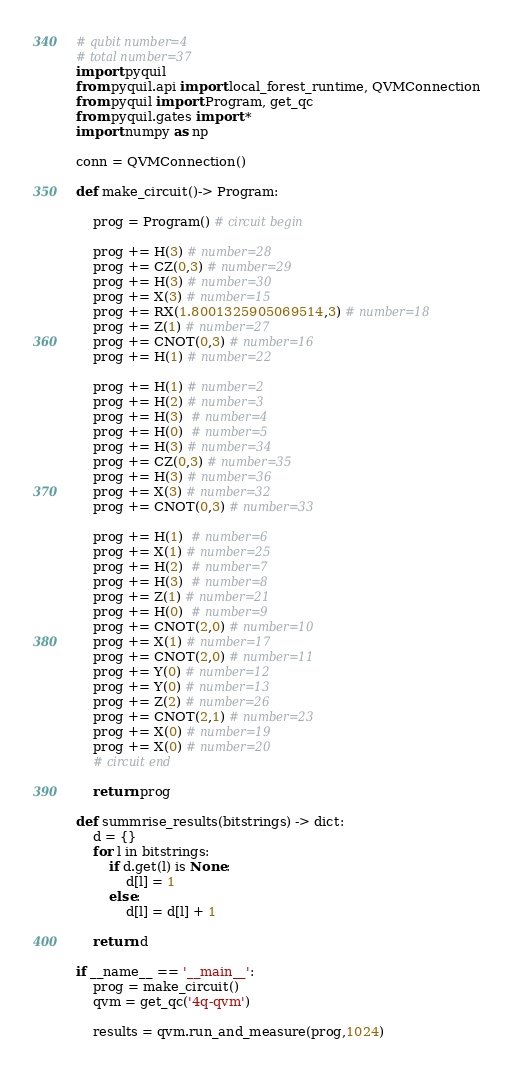Convert code to text. <code><loc_0><loc_0><loc_500><loc_500><_Python_># qubit number=4
# total number=37
import pyquil
from pyquil.api import local_forest_runtime, QVMConnection
from pyquil import Program, get_qc
from pyquil.gates import *
import numpy as np

conn = QVMConnection()

def make_circuit()-> Program:

    prog = Program() # circuit begin

    prog += H(3) # number=28
    prog += CZ(0,3) # number=29
    prog += H(3) # number=30
    prog += X(3) # number=15
    prog += RX(1.8001325905069514,3) # number=18
    prog += Z(1) # number=27
    prog += CNOT(0,3) # number=16
    prog += H(1) # number=22

    prog += H(1) # number=2
    prog += H(2) # number=3
    prog += H(3)  # number=4
    prog += H(0)  # number=5
    prog += H(3) # number=34
    prog += CZ(0,3) # number=35
    prog += H(3) # number=36
    prog += X(3) # number=32
    prog += CNOT(0,3) # number=33

    prog += H(1)  # number=6
    prog += X(1) # number=25
    prog += H(2)  # number=7
    prog += H(3)  # number=8
    prog += Z(1) # number=21
    prog += H(0)  # number=9
    prog += CNOT(2,0) # number=10
    prog += X(1) # number=17
    prog += CNOT(2,0) # number=11
    prog += Y(0) # number=12
    prog += Y(0) # number=13
    prog += Z(2) # number=26
    prog += CNOT(2,1) # number=23
    prog += X(0) # number=19
    prog += X(0) # number=20
    # circuit end

    return prog

def summrise_results(bitstrings) -> dict:
    d = {}
    for l in bitstrings:
        if d.get(l) is None:
            d[l] = 1
        else:
            d[l] = d[l] + 1

    return d

if __name__ == '__main__':
    prog = make_circuit()
    qvm = get_qc('4q-qvm')

    results = qvm.run_and_measure(prog,1024)</code> 